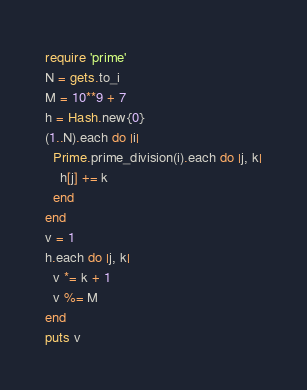Convert code to text. <code><loc_0><loc_0><loc_500><loc_500><_Ruby_>require 'prime'
N = gets.to_i
M = 10**9 + 7
h = Hash.new{0}
(1..N).each do |i|
  Prime.prime_division(i).each do |j, k|
    h[j] += k
  end
end
v = 1
h.each do |j, k|
  v *= k + 1
  v %= M
end
puts v
</code> 